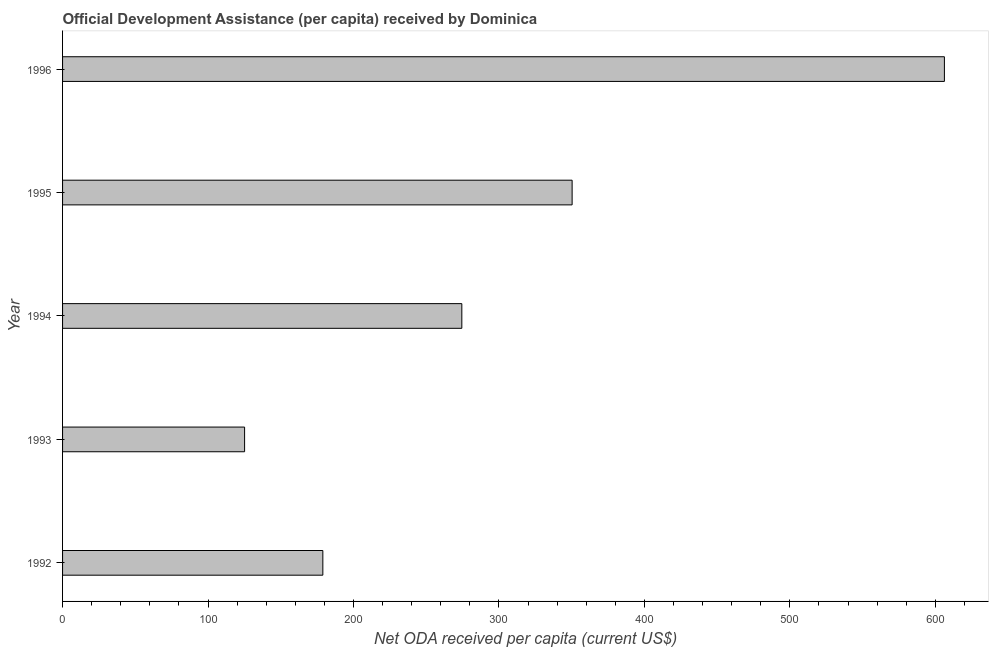What is the title of the graph?
Keep it short and to the point. Official Development Assistance (per capita) received by Dominica. What is the label or title of the X-axis?
Keep it short and to the point. Net ODA received per capita (current US$). What is the label or title of the Y-axis?
Offer a terse response. Year. What is the net oda received per capita in 1992?
Give a very brief answer. 178.93. Across all years, what is the maximum net oda received per capita?
Your answer should be compact. 606.22. Across all years, what is the minimum net oda received per capita?
Offer a terse response. 125.13. In which year was the net oda received per capita minimum?
Your response must be concise. 1993. What is the sum of the net oda received per capita?
Offer a terse response. 1535.06. What is the difference between the net oda received per capita in 1993 and 1994?
Make the answer very short. -149.35. What is the average net oda received per capita per year?
Provide a short and direct response. 307.01. What is the median net oda received per capita?
Keep it short and to the point. 274.48. What is the ratio of the net oda received per capita in 1992 to that in 1993?
Your answer should be very brief. 1.43. What is the difference between the highest and the second highest net oda received per capita?
Ensure brevity in your answer.  255.92. Is the sum of the net oda received per capita in 1994 and 1996 greater than the maximum net oda received per capita across all years?
Your response must be concise. Yes. What is the difference between the highest and the lowest net oda received per capita?
Make the answer very short. 481.09. In how many years, is the net oda received per capita greater than the average net oda received per capita taken over all years?
Provide a succinct answer. 2. How many bars are there?
Offer a terse response. 5. How many years are there in the graph?
Make the answer very short. 5. What is the Net ODA received per capita (current US$) of 1992?
Offer a very short reply. 178.93. What is the Net ODA received per capita (current US$) in 1993?
Ensure brevity in your answer.  125.13. What is the Net ODA received per capita (current US$) in 1994?
Your answer should be compact. 274.48. What is the Net ODA received per capita (current US$) of 1995?
Provide a succinct answer. 350.3. What is the Net ODA received per capita (current US$) in 1996?
Ensure brevity in your answer.  606.22. What is the difference between the Net ODA received per capita (current US$) in 1992 and 1993?
Offer a terse response. 53.8. What is the difference between the Net ODA received per capita (current US$) in 1992 and 1994?
Your answer should be compact. -95.55. What is the difference between the Net ODA received per capita (current US$) in 1992 and 1995?
Your answer should be compact. -171.37. What is the difference between the Net ODA received per capita (current US$) in 1992 and 1996?
Offer a terse response. -427.29. What is the difference between the Net ODA received per capita (current US$) in 1993 and 1994?
Provide a succinct answer. -149.35. What is the difference between the Net ODA received per capita (current US$) in 1993 and 1995?
Offer a terse response. -225.17. What is the difference between the Net ODA received per capita (current US$) in 1993 and 1996?
Your response must be concise. -481.09. What is the difference between the Net ODA received per capita (current US$) in 1994 and 1995?
Ensure brevity in your answer.  -75.82. What is the difference between the Net ODA received per capita (current US$) in 1994 and 1996?
Ensure brevity in your answer.  -331.74. What is the difference between the Net ODA received per capita (current US$) in 1995 and 1996?
Give a very brief answer. -255.92. What is the ratio of the Net ODA received per capita (current US$) in 1992 to that in 1993?
Your response must be concise. 1.43. What is the ratio of the Net ODA received per capita (current US$) in 1992 to that in 1994?
Offer a terse response. 0.65. What is the ratio of the Net ODA received per capita (current US$) in 1992 to that in 1995?
Make the answer very short. 0.51. What is the ratio of the Net ODA received per capita (current US$) in 1992 to that in 1996?
Provide a succinct answer. 0.29. What is the ratio of the Net ODA received per capita (current US$) in 1993 to that in 1994?
Your answer should be compact. 0.46. What is the ratio of the Net ODA received per capita (current US$) in 1993 to that in 1995?
Your response must be concise. 0.36. What is the ratio of the Net ODA received per capita (current US$) in 1993 to that in 1996?
Offer a very short reply. 0.21. What is the ratio of the Net ODA received per capita (current US$) in 1994 to that in 1995?
Offer a very short reply. 0.78. What is the ratio of the Net ODA received per capita (current US$) in 1994 to that in 1996?
Your response must be concise. 0.45. What is the ratio of the Net ODA received per capita (current US$) in 1995 to that in 1996?
Give a very brief answer. 0.58. 